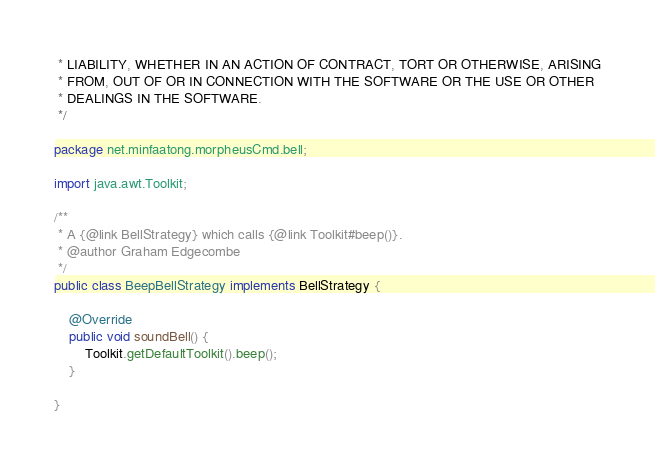<code> <loc_0><loc_0><loc_500><loc_500><_Java_> * LIABILITY, WHETHER IN AN ACTION OF CONTRACT, TORT OR OTHERWISE, ARISING
 * FROM, OUT OF OR IN CONNECTION WITH THE SOFTWARE OR THE USE OR OTHER
 * DEALINGS IN THE SOFTWARE.
 */

package net.minfaatong.morpheusCmd.bell;

import java.awt.Toolkit;

/**
 * A {@link BellStrategy} which calls {@link Toolkit#beep()}.
 * @author Graham Edgecombe
 */
public class BeepBellStrategy implements BellStrategy {

	@Override
	public void soundBell() {
		Toolkit.getDefaultToolkit().beep();
	}

}

</code> 